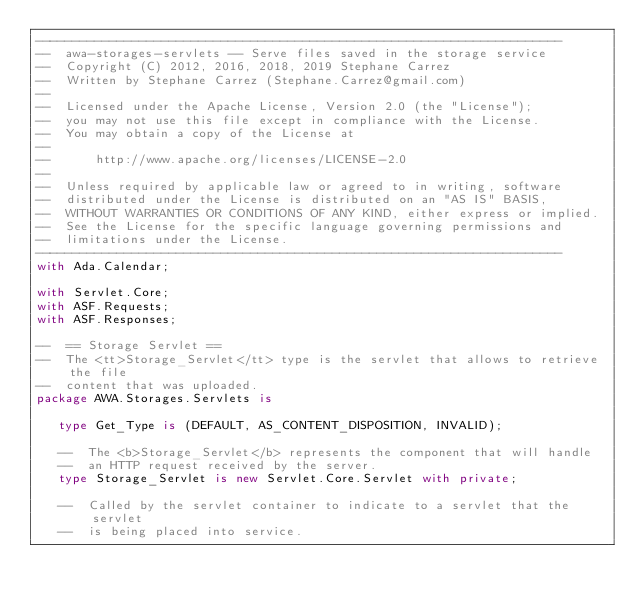Convert code to text. <code><loc_0><loc_0><loc_500><loc_500><_Ada_>-----------------------------------------------------------------------
--  awa-storages-servlets -- Serve files saved in the storage service
--  Copyright (C) 2012, 2016, 2018, 2019 Stephane Carrez
--  Written by Stephane Carrez (Stephane.Carrez@gmail.com)
--
--  Licensed under the Apache License, Version 2.0 (the "License");
--  you may not use this file except in compliance with the License.
--  You may obtain a copy of the License at
--
--      http://www.apache.org/licenses/LICENSE-2.0
--
--  Unless required by applicable law or agreed to in writing, software
--  distributed under the License is distributed on an "AS IS" BASIS,
--  WITHOUT WARRANTIES OR CONDITIONS OF ANY KIND, either express or implied.
--  See the License for the specific language governing permissions and
--  limitations under the License.
-----------------------------------------------------------------------
with Ada.Calendar;

with Servlet.Core;
with ASF.Requests;
with ASF.Responses;

--  == Storage Servlet ==
--  The <tt>Storage_Servlet</tt> type is the servlet that allows to retrieve the file
--  content that was uploaded.
package AWA.Storages.Servlets is

   type Get_Type is (DEFAULT, AS_CONTENT_DISPOSITION, INVALID);

   --  The <b>Storage_Servlet</b> represents the component that will handle
   --  an HTTP request received by the server.
   type Storage_Servlet is new Servlet.Core.Servlet with private;

   --  Called by the servlet container to indicate to a servlet that the servlet
   --  is being placed into service.</code> 